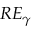<formula> <loc_0><loc_0><loc_500><loc_500>R E _ { \gamma }</formula> 